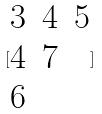Convert formula to latex. <formula><loc_0><loc_0><loc_500><loc_500>[ \begin{matrix} 3 & 4 & 5 \\ 4 & 7 \\ 6 \end{matrix} ]</formula> 